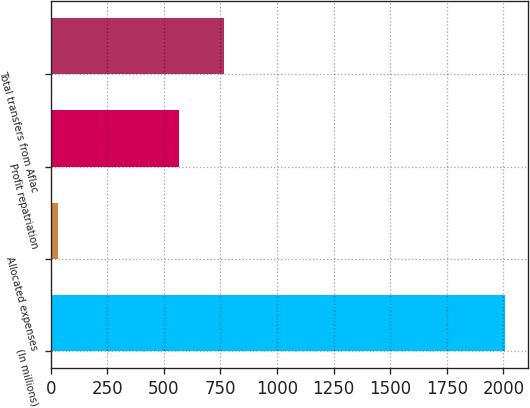<chart> <loc_0><loc_0><loc_500><loc_500><bar_chart><fcel>(In millions)<fcel>Allocated expenses<fcel>Profit repatriation<fcel>Total transfers from Aflac<nl><fcel>2007<fcel>33<fcel>567<fcel>764.4<nl></chart> 